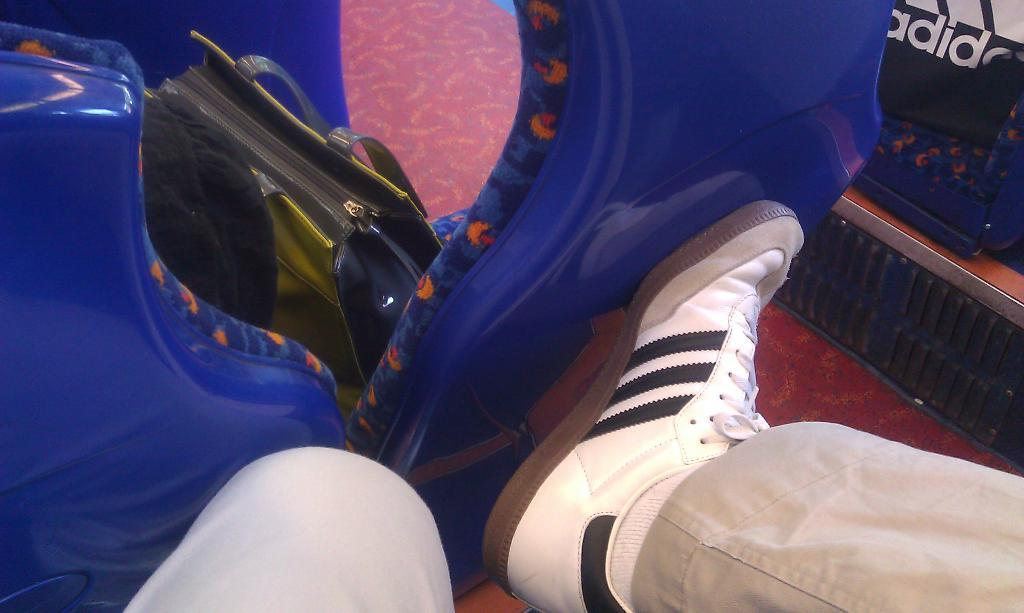What part of a person can be seen in the image? There is a person's leg visible in the image. What is the person wearing on their leg? The person is wearing a shoe. What type of object is present in the image that can be used for carrying items? There is a bag in the image. What type of furniture is present in the image? There is a stool in the image. What type of surface is visible in the image that can be walked on? There is a path in the image. Can you describe any other objects present in the image? There are other unspecified objects in the image. Can you hear the bee buzzing in the image? There is no bee present in the image, so it is not possible to hear it buzzing. 